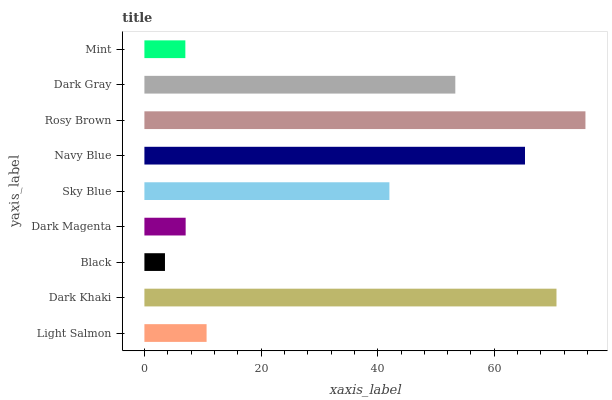Is Black the minimum?
Answer yes or no. Yes. Is Rosy Brown the maximum?
Answer yes or no. Yes. Is Dark Khaki the minimum?
Answer yes or no. No. Is Dark Khaki the maximum?
Answer yes or no. No. Is Dark Khaki greater than Light Salmon?
Answer yes or no. Yes. Is Light Salmon less than Dark Khaki?
Answer yes or no. Yes. Is Light Salmon greater than Dark Khaki?
Answer yes or no. No. Is Dark Khaki less than Light Salmon?
Answer yes or no. No. Is Sky Blue the high median?
Answer yes or no. Yes. Is Sky Blue the low median?
Answer yes or no. Yes. Is Mint the high median?
Answer yes or no. No. Is Light Salmon the low median?
Answer yes or no. No. 